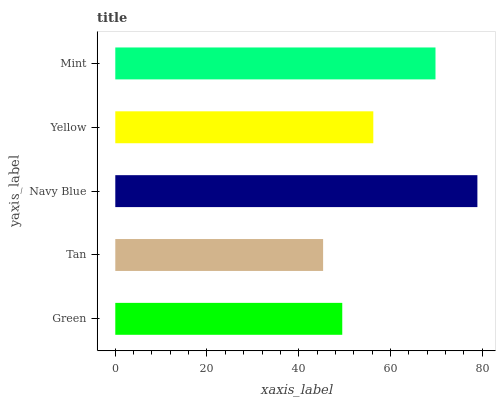Is Tan the minimum?
Answer yes or no. Yes. Is Navy Blue the maximum?
Answer yes or no. Yes. Is Navy Blue the minimum?
Answer yes or no. No. Is Tan the maximum?
Answer yes or no. No. Is Navy Blue greater than Tan?
Answer yes or no. Yes. Is Tan less than Navy Blue?
Answer yes or no. Yes. Is Tan greater than Navy Blue?
Answer yes or no. No. Is Navy Blue less than Tan?
Answer yes or no. No. Is Yellow the high median?
Answer yes or no. Yes. Is Yellow the low median?
Answer yes or no. Yes. Is Mint the high median?
Answer yes or no. No. Is Navy Blue the low median?
Answer yes or no. No. 